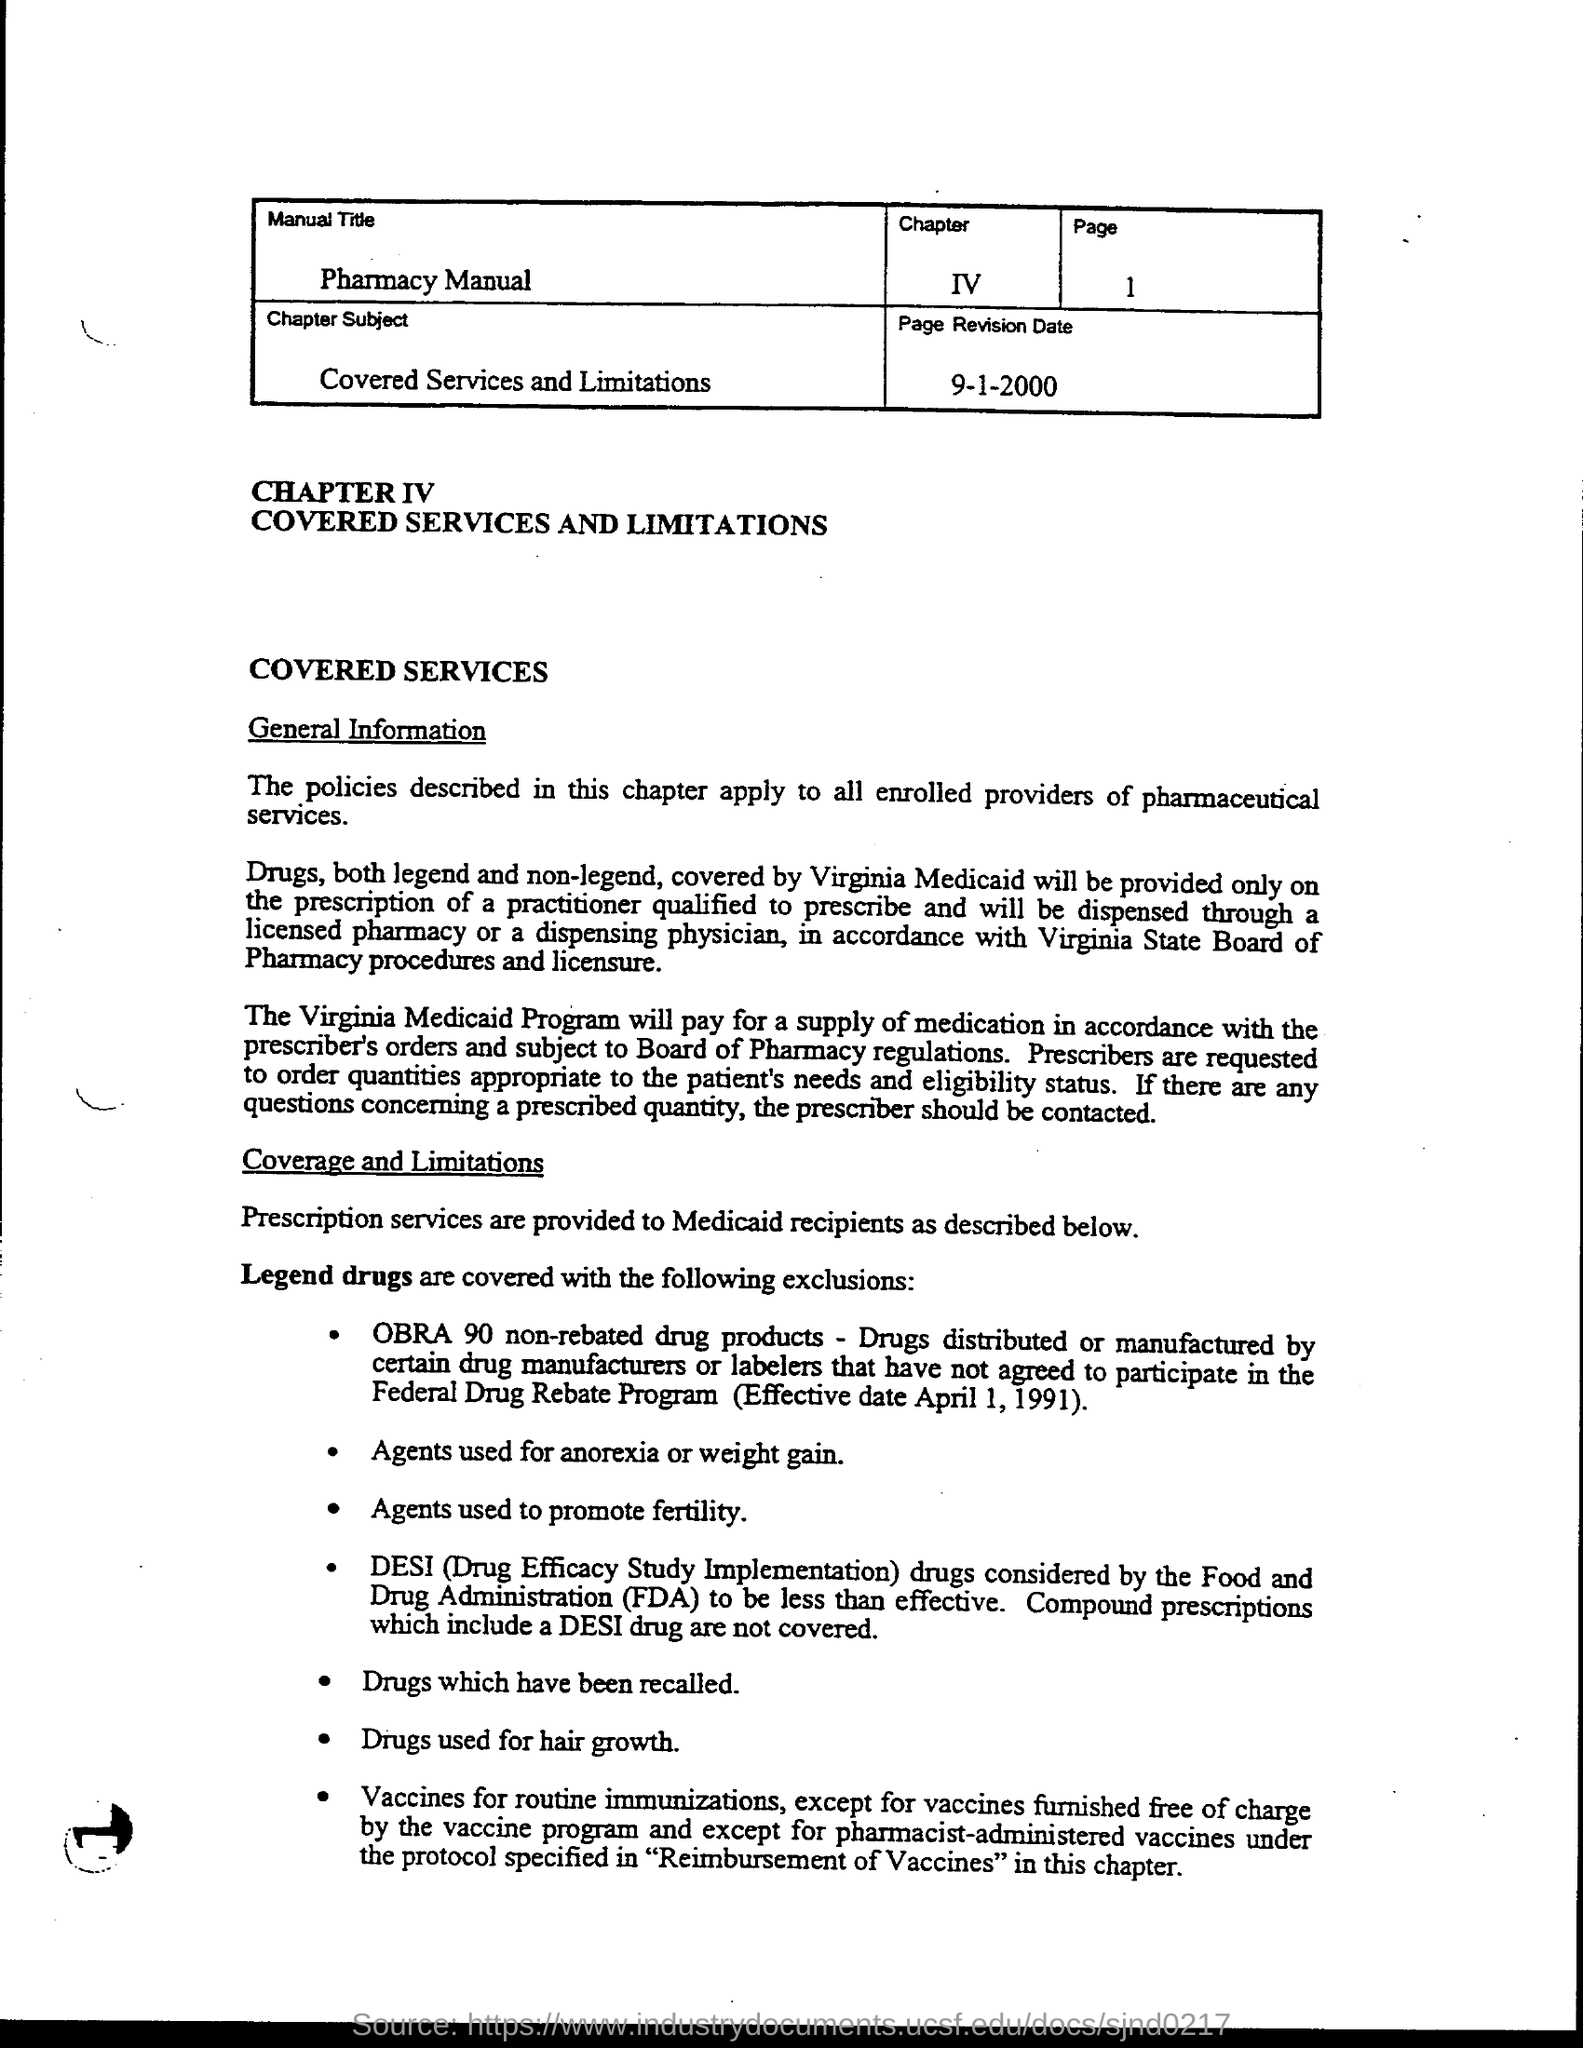What is the Manual Title?
Keep it short and to the point. Pharmacy Manual. What is the chapter subject?
Provide a short and direct response. Covered Services and Limitations. What is the page?
Keep it short and to the point. 1. What is the page revision date?
Provide a succinct answer. 9-1-2000. What does DESI stand for?
Ensure brevity in your answer.  Drug Efficacy Study Implementation. What does FDA stand for?
Your response must be concise. Food and Drug Administration. 